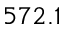<formula> <loc_0><loc_0><loc_500><loc_500>5 7 2 . 1</formula> 